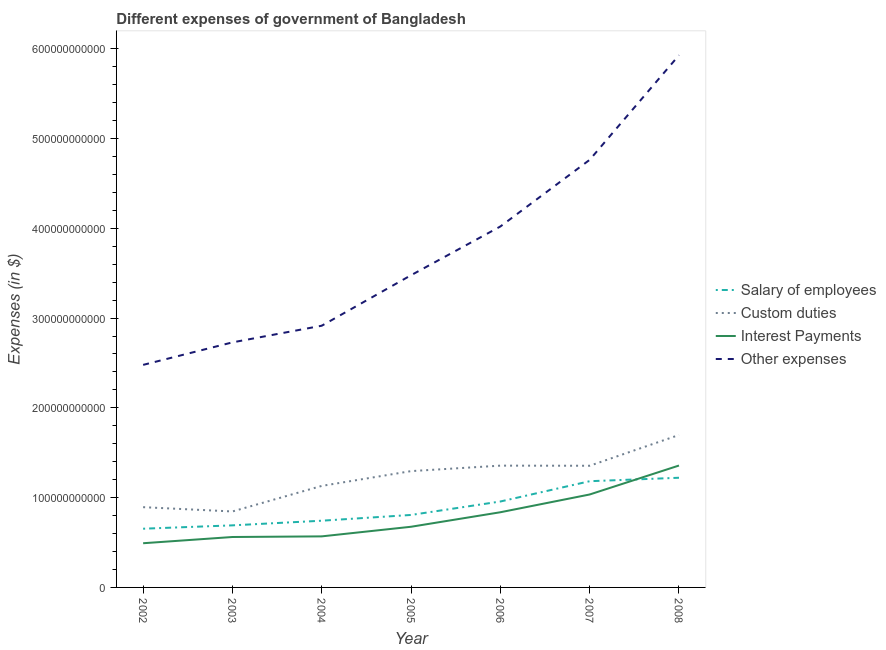Does the line corresponding to amount spent on custom duties intersect with the line corresponding to amount spent on other expenses?
Make the answer very short. No. Is the number of lines equal to the number of legend labels?
Your answer should be very brief. Yes. What is the amount spent on other expenses in 2006?
Provide a short and direct response. 4.02e+11. Across all years, what is the maximum amount spent on interest payments?
Your answer should be compact. 1.36e+11. Across all years, what is the minimum amount spent on salary of employees?
Offer a very short reply. 6.54e+1. In which year was the amount spent on salary of employees maximum?
Your answer should be compact. 2008. In which year was the amount spent on custom duties minimum?
Ensure brevity in your answer.  2003. What is the total amount spent on salary of employees in the graph?
Your answer should be very brief. 6.26e+11. What is the difference between the amount spent on custom duties in 2002 and that in 2003?
Your response must be concise. 4.78e+09. What is the difference between the amount spent on salary of employees in 2006 and the amount spent on other expenses in 2008?
Keep it short and to the point. -4.97e+11. What is the average amount spent on other expenses per year?
Your answer should be very brief. 3.76e+11. In the year 2008, what is the difference between the amount spent on custom duties and amount spent on interest payments?
Make the answer very short. 3.40e+1. What is the ratio of the amount spent on interest payments in 2007 to that in 2008?
Provide a short and direct response. 0.76. Is the amount spent on interest payments in 2004 less than that in 2007?
Offer a very short reply. Yes. What is the difference between the highest and the second highest amount spent on other expenses?
Offer a very short reply. 1.16e+11. What is the difference between the highest and the lowest amount spent on salary of employees?
Your response must be concise. 5.68e+1. Is the sum of the amount spent on other expenses in 2004 and 2008 greater than the maximum amount spent on interest payments across all years?
Keep it short and to the point. Yes. Is it the case that in every year, the sum of the amount spent on custom duties and amount spent on salary of employees is greater than the sum of amount spent on interest payments and amount spent on other expenses?
Offer a terse response. No. How many lines are there?
Make the answer very short. 4. What is the difference between two consecutive major ticks on the Y-axis?
Offer a very short reply. 1.00e+11. Are the values on the major ticks of Y-axis written in scientific E-notation?
Offer a terse response. No. Does the graph contain grids?
Make the answer very short. No. Where does the legend appear in the graph?
Make the answer very short. Center right. How are the legend labels stacked?
Keep it short and to the point. Vertical. What is the title of the graph?
Ensure brevity in your answer.  Different expenses of government of Bangladesh. What is the label or title of the X-axis?
Provide a succinct answer. Year. What is the label or title of the Y-axis?
Provide a succinct answer. Expenses (in $). What is the Expenses (in $) in Salary of employees in 2002?
Give a very brief answer. 6.54e+1. What is the Expenses (in $) of Custom duties in 2002?
Ensure brevity in your answer.  8.94e+1. What is the Expenses (in $) of Interest Payments in 2002?
Give a very brief answer. 4.92e+1. What is the Expenses (in $) of Other expenses in 2002?
Offer a terse response. 2.48e+11. What is the Expenses (in $) in Salary of employees in 2003?
Offer a very short reply. 6.91e+1. What is the Expenses (in $) in Custom duties in 2003?
Keep it short and to the point. 8.46e+1. What is the Expenses (in $) in Interest Payments in 2003?
Ensure brevity in your answer.  5.62e+1. What is the Expenses (in $) in Other expenses in 2003?
Give a very brief answer. 2.73e+11. What is the Expenses (in $) of Salary of employees in 2004?
Offer a very short reply. 7.43e+1. What is the Expenses (in $) of Custom duties in 2004?
Provide a succinct answer. 1.13e+11. What is the Expenses (in $) of Interest Payments in 2004?
Your answer should be compact. 5.69e+1. What is the Expenses (in $) of Other expenses in 2004?
Offer a very short reply. 2.91e+11. What is the Expenses (in $) in Salary of employees in 2005?
Give a very brief answer. 8.07e+1. What is the Expenses (in $) of Custom duties in 2005?
Your answer should be very brief. 1.30e+11. What is the Expenses (in $) of Interest Payments in 2005?
Offer a very short reply. 6.76e+1. What is the Expenses (in $) in Other expenses in 2005?
Provide a short and direct response. 3.48e+11. What is the Expenses (in $) of Salary of employees in 2006?
Keep it short and to the point. 9.57e+1. What is the Expenses (in $) of Custom duties in 2006?
Give a very brief answer. 1.36e+11. What is the Expenses (in $) in Interest Payments in 2006?
Provide a succinct answer. 8.37e+1. What is the Expenses (in $) in Other expenses in 2006?
Your response must be concise. 4.02e+11. What is the Expenses (in $) in Salary of employees in 2007?
Make the answer very short. 1.18e+11. What is the Expenses (in $) in Custom duties in 2007?
Offer a terse response. 1.36e+11. What is the Expenses (in $) in Interest Payments in 2007?
Offer a very short reply. 1.04e+11. What is the Expenses (in $) of Other expenses in 2007?
Your answer should be very brief. 4.76e+11. What is the Expenses (in $) of Salary of employees in 2008?
Keep it short and to the point. 1.22e+11. What is the Expenses (in $) of Custom duties in 2008?
Your answer should be very brief. 1.70e+11. What is the Expenses (in $) of Interest Payments in 2008?
Your answer should be compact. 1.36e+11. What is the Expenses (in $) in Other expenses in 2008?
Your answer should be very brief. 5.93e+11. Across all years, what is the maximum Expenses (in $) of Salary of employees?
Keep it short and to the point. 1.22e+11. Across all years, what is the maximum Expenses (in $) of Custom duties?
Keep it short and to the point. 1.70e+11. Across all years, what is the maximum Expenses (in $) in Interest Payments?
Offer a terse response. 1.36e+11. Across all years, what is the maximum Expenses (in $) of Other expenses?
Your response must be concise. 5.93e+11. Across all years, what is the minimum Expenses (in $) in Salary of employees?
Keep it short and to the point. 6.54e+1. Across all years, what is the minimum Expenses (in $) of Custom duties?
Your response must be concise. 8.46e+1. Across all years, what is the minimum Expenses (in $) in Interest Payments?
Ensure brevity in your answer.  4.92e+1. Across all years, what is the minimum Expenses (in $) in Other expenses?
Provide a succinct answer. 2.48e+11. What is the total Expenses (in $) of Salary of employees in the graph?
Ensure brevity in your answer.  6.26e+11. What is the total Expenses (in $) in Custom duties in the graph?
Offer a very short reply. 8.58e+11. What is the total Expenses (in $) of Interest Payments in the graph?
Provide a succinct answer. 5.53e+11. What is the total Expenses (in $) in Other expenses in the graph?
Provide a short and direct response. 2.63e+12. What is the difference between the Expenses (in $) of Salary of employees in 2002 and that in 2003?
Ensure brevity in your answer.  -3.74e+09. What is the difference between the Expenses (in $) of Custom duties in 2002 and that in 2003?
Make the answer very short. 4.78e+09. What is the difference between the Expenses (in $) of Interest Payments in 2002 and that in 2003?
Offer a terse response. -6.94e+09. What is the difference between the Expenses (in $) of Other expenses in 2002 and that in 2003?
Your answer should be very brief. -2.51e+1. What is the difference between the Expenses (in $) in Salary of employees in 2002 and that in 2004?
Offer a very short reply. -8.92e+09. What is the difference between the Expenses (in $) of Custom duties in 2002 and that in 2004?
Keep it short and to the point. -2.37e+1. What is the difference between the Expenses (in $) in Interest Payments in 2002 and that in 2004?
Offer a terse response. -7.65e+09. What is the difference between the Expenses (in $) in Other expenses in 2002 and that in 2004?
Offer a very short reply. -4.36e+1. What is the difference between the Expenses (in $) of Salary of employees in 2002 and that in 2005?
Your answer should be very brief. -1.53e+1. What is the difference between the Expenses (in $) of Custom duties in 2002 and that in 2005?
Offer a terse response. -4.02e+1. What is the difference between the Expenses (in $) of Interest Payments in 2002 and that in 2005?
Ensure brevity in your answer.  -1.84e+1. What is the difference between the Expenses (in $) of Other expenses in 2002 and that in 2005?
Your answer should be very brief. -9.99e+1. What is the difference between the Expenses (in $) of Salary of employees in 2002 and that in 2006?
Make the answer very short. -3.03e+1. What is the difference between the Expenses (in $) of Custom duties in 2002 and that in 2006?
Your answer should be very brief. -4.63e+1. What is the difference between the Expenses (in $) of Interest Payments in 2002 and that in 2006?
Make the answer very short. -3.45e+1. What is the difference between the Expenses (in $) of Other expenses in 2002 and that in 2006?
Keep it short and to the point. -1.54e+11. What is the difference between the Expenses (in $) in Salary of employees in 2002 and that in 2007?
Offer a terse response. -5.29e+1. What is the difference between the Expenses (in $) in Custom duties in 2002 and that in 2007?
Provide a succinct answer. -4.61e+1. What is the difference between the Expenses (in $) of Interest Payments in 2002 and that in 2007?
Your response must be concise. -5.43e+1. What is the difference between the Expenses (in $) of Other expenses in 2002 and that in 2007?
Offer a very short reply. -2.28e+11. What is the difference between the Expenses (in $) of Salary of employees in 2002 and that in 2008?
Provide a succinct answer. -5.68e+1. What is the difference between the Expenses (in $) of Custom duties in 2002 and that in 2008?
Offer a very short reply. -8.04e+1. What is the difference between the Expenses (in $) of Interest Payments in 2002 and that in 2008?
Your response must be concise. -8.66e+1. What is the difference between the Expenses (in $) of Other expenses in 2002 and that in 2008?
Provide a short and direct response. -3.45e+11. What is the difference between the Expenses (in $) of Salary of employees in 2003 and that in 2004?
Your answer should be compact. -5.18e+09. What is the difference between the Expenses (in $) in Custom duties in 2003 and that in 2004?
Your response must be concise. -2.85e+1. What is the difference between the Expenses (in $) in Interest Payments in 2003 and that in 2004?
Offer a terse response. -7.04e+08. What is the difference between the Expenses (in $) of Other expenses in 2003 and that in 2004?
Make the answer very short. -1.85e+1. What is the difference between the Expenses (in $) in Salary of employees in 2003 and that in 2005?
Give a very brief answer. -1.16e+1. What is the difference between the Expenses (in $) of Custom duties in 2003 and that in 2005?
Provide a short and direct response. -4.49e+1. What is the difference between the Expenses (in $) of Interest Payments in 2003 and that in 2005?
Ensure brevity in your answer.  -1.14e+1. What is the difference between the Expenses (in $) of Other expenses in 2003 and that in 2005?
Ensure brevity in your answer.  -7.48e+1. What is the difference between the Expenses (in $) of Salary of employees in 2003 and that in 2006?
Offer a very short reply. -2.66e+1. What is the difference between the Expenses (in $) of Custom duties in 2003 and that in 2006?
Offer a very short reply. -5.10e+1. What is the difference between the Expenses (in $) in Interest Payments in 2003 and that in 2006?
Your response must be concise. -2.76e+1. What is the difference between the Expenses (in $) in Other expenses in 2003 and that in 2006?
Give a very brief answer. -1.29e+11. What is the difference between the Expenses (in $) in Salary of employees in 2003 and that in 2007?
Ensure brevity in your answer.  -4.92e+1. What is the difference between the Expenses (in $) in Custom duties in 2003 and that in 2007?
Offer a very short reply. -5.09e+1. What is the difference between the Expenses (in $) in Interest Payments in 2003 and that in 2007?
Provide a short and direct response. -4.74e+1. What is the difference between the Expenses (in $) of Other expenses in 2003 and that in 2007?
Keep it short and to the point. -2.03e+11. What is the difference between the Expenses (in $) of Salary of employees in 2003 and that in 2008?
Ensure brevity in your answer.  -5.30e+1. What is the difference between the Expenses (in $) of Custom duties in 2003 and that in 2008?
Provide a short and direct response. -8.52e+1. What is the difference between the Expenses (in $) in Interest Payments in 2003 and that in 2008?
Provide a succinct answer. -7.96e+1. What is the difference between the Expenses (in $) of Other expenses in 2003 and that in 2008?
Give a very brief answer. -3.20e+11. What is the difference between the Expenses (in $) of Salary of employees in 2004 and that in 2005?
Keep it short and to the point. -6.42e+09. What is the difference between the Expenses (in $) of Custom duties in 2004 and that in 2005?
Keep it short and to the point. -1.65e+1. What is the difference between the Expenses (in $) of Interest Payments in 2004 and that in 2005?
Offer a terse response. -1.07e+1. What is the difference between the Expenses (in $) of Other expenses in 2004 and that in 2005?
Offer a terse response. -5.63e+1. What is the difference between the Expenses (in $) of Salary of employees in 2004 and that in 2006?
Provide a succinct answer. -2.14e+1. What is the difference between the Expenses (in $) in Custom duties in 2004 and that in 2006?
Your answer should be compact. -2.26e+1. What is the difference between the Expenses (in $) of Interest Payments in 2004 and that in 2006?
Ensure brevity in your answer.  -2.69e+1. What is the difference between the Expenses (in $) in Other expenses in 2004 and that in 2006?
Give a very brief answer. -1.11e+11. What is the difference between the Expenses (in $) in Salary of employees in 2004 and that in 2007?
Provide a succinct answer. -4.40e+1. What is the difference between the Expenses (in $) of Custom duties in 2004 and that in 2007?
Make the answer very short. -2.24e+1. What is the difference between the Expenses (in $) of Interest Payments in 2004 and that in 2007?
Your response must be concise. -4.67e+1. What is the difference between the Expenses (in $) in Other expenses in 2004 and that in 2007?
Give a very brief answer. -1.85e+11. What is the difference between the Expenses (in $) of Salary of employees in 2004 and that in 2008?
Your answer should be very brief. -4.78e+1. What is the difference between the Expenses (in $) of Custom duties in 2004 and that in 2008?
Provide a short and direct response. -5.67e+1. What is the difference between the Expenses (in $) in Interest Payments in 2004 and that in 2008?
Your answer should be very brief. -7.89e+1. What is the difference between the Expenses (in $) of Other expenses in 2004 and that in 2008?
Offer a very short reply. -3.01e+11. What is the difference between the Expenses (in $) of Salary of employees in 2005 and that in 2006?
Your answer should be very brief. -1.50e+1. What is the difference between the Expenses (in $) of Custom duties in 2005 and that in 2006?
Provide a succinct answer. -6.10e+09. What is the difference between the Expenses (in $) of Interest Payments in 2005 and that in 2006?
Provide a short and direct response. -1.62e+1. What is the difference between the Expenses (in $) in Other expenses in 2005 and that in 2006?
Offer a very short reply. -5.43e+1. What is the difference between the Expenses (in $) of Salary of employees in 2005 and that in 2007?
Ensure brevity in your answer.  -3.76e+1. What is the difference between the Expenses (in $) in Custom duties in 2005 and that in 2007?
Ensure brevity in your answer.  -5.96e+09. What is the difference between the Expenses (in $) of Interest Payments in 2005 and that in 2007?
Your answer should be very brief. -3.59e+1. What is the difference between the Expenses (in $) of Other expenses in 2005 and that in 2007?
Ensure brevity in your answer.  -1.29e+11. What is the difference between the Expenses (in $) of Salary of employees in 2005 and that in 2008?
Keep it short and to the point. -4.14e+1. What is the difference between the Expenses (in $) in Custom duties in 2005 and that in 2008?
Your answer should be very brief. -4.02e+1. What is the difference between the Expenses (in $) of Interest Payments in 2005 and that in 2008?
Provide a short and direct response. -6.82e+1. What is the difference between the Expenses (in $) in Other expenses in 2005 and that in 2008?
Make the answer very short. -2.45e+11. What is the difference between the Expenses (in $) of Salary of employees in 2006 and that in 2007?
Make the answer very short. -2.26e+1. What is the difference between the Expenses (in $) in Custom duties in 2006 and that in 2007?
Offer a terse response. 1.33e+08. What is the difference between the Expenses (in $) of Interest Payments in 2006 and that in 2007?
Offer a very short reply. -1.98e+1. What is the difference between the Expenses (in $) in Other expenses in 2006 and that in 2007?
Give a very brief answer. -7.43e+1. What is the difference between the Expenses (in $) of Salary of employees in 2006 and that in 2008?
Provide a succinct answer. -2.65e+1. What is the difference between the Expenses (in $) in Custom duties in 2006 and that in 2008?
Provide a short and direct response. -3.41e+1. What is the difference between the Expenses (in $) of Interest Payments in 2006 and that in 2008?
Give a very brief answer. -5.20e+1. What is the difference between the Expenses (in $) of Other expenses in 2006 and that in 2008?
Keep it short and to the point. -1.91e+11. What is the difference between the Expenses (in $) of Salary of employees in 2007 and that in 2008?
Your response must be concise. -3.86e+09. What is the difference between the Expenses (in $) of Custom duties in 2007 and that in 2008?
Your answer should be very brief. -3.43e+1. What is the difference between the Expenses (in $) of Interest Payments in 2007 and that in 2008?
Your answer should be very brief. -3.23e+1. What is the difference between the Expenses (in $) of Other expenses in 2007 and that in 2008?
Your answer should be very brief. -1.16e+11. What is the difference between the Expenses (in $) of Salary of employees in 2002 and the Expenses (in $) of Custom duties in 2003?
Ensure brevity in your answer.  -1.92e+1. What is the difference between the Expenses (in $) of Salary of employees in 2002 and the Expenses (in $) of Interest Payments in 2003?
Ensure brevity in your answer.  9.23e+09. What is the difference between the Expenses (in $) of Salary of employees in 2002 and the Expenses (in $) of Other expenses in 2003?
Your response must be concise. -2.08e+11. What is the difference between the Expenses (in $) in Custom duties in 2002 and the Expenses (in $) in Interest Payments in 2003?
Offer a terse response. 3.32e+1. What is the difference between the Expenses (in $) of Custom duties in 2002 and the Expenses (in $) of Other expenses in 2003?
Provide a short and direct response. -1.84e+11. What is the difference between the Expenses (in $) in Interest Payments in 2002 and the Expenses (in $) in Other expenses in 2003?
Your answer should be very brief. -2.24e+11. What is the difference between the Expenses (in $) in Salary of employees in 2002 and the Expenses (in $) in Custom duties in 2004?
Offer a very short reply. -4.77e+1. What is the difference between the Expenses (in $) of Salary of employees in 2002 and the Expenses (in $) of Interest Payments in 2004?
Keep it short and to the point. 8.53e+09. What is the difference between the Expenses (in $) in Salary of employees in 2002 and the Expenses (in $) in Other expenses in 2004?
Keep it short and to the point. -2.26e+11. What is the difference between the Expenses (in $) in Custom duties in 2002 and the Expenses (in $) in Interest Payments in 2004?
Give a very brief answer. 3.25e+1. What is the difference between the Expenses (in $) in Custom duties in 2002 and the Expenses (in $) in Other expenses in 2004?
Ensure brevity in your answer.  -2.02e+11. What is the difference between the Expenses (in $) of Interest Payments in 2002 and the Expenses (in $) of Other expenses in 2004?
Your answer should be compact. -2.42e+11. What is the difference between the Expenses (in $) in Salary of employees in 2002 and the Expenses (in $) in Custom duties in 2005?
Make the answer very short. -6.42e+1. What is the difference between the Expenses (in $) in Salary of employees in 2002 and the Expenses (in $) in Interest Payments in 2005?
Provide a short and direct response. -2.18e+09. What is the difference between the Expenses (in $) in Salary of employees in 2002 and the Expenses (in $) in Other expenses in 2005?
Ensure brevity in your answer.  -2.82e+11. What is the difference between the Expenses (in $) of Custom duties in 2002 and the Expenses (in $) of Interest Payments in 2005?
Your answer should be very brief. 2.18e+1. What is the difference between the Expenses (in $) in Custom duties in 2002 and the Expenses (in $) in Other expenses in 2005?
Make the answer very short. -2.58e+11. What is the difference between the Expenses (in $) of Interest Payments in 2002 and the Expenses (in $) of Other expenses in 2005?
Ensure brevity in your answer.  -2.99e+11. What is the difference between the Expenses (in $) in Salary of employees in 2002 and the Expenses (in $) in Custom duties in 2006?
Offer a terse response. -7.03e+1. What is the difference between the Expenses (in $) of Salary of employees in 2002 and the Expenses (in $) of Interest Payments in 2006?
Give a very brief answer. -1.83e+1. What is the difference between the Expenses (in $) of Salary of employees in 2002 and the Expenses (in $) of Other expenses in 2006?
Ensure brevity in your answer.  -3.37e+11. What is the difference between the Expenses (in $) of Custom duties in 2002 and the Expenses (in $) of Interest Payments in 2006?
Your response must be concise. 5.66e+09. What is the difference between the Expenses (in $) in Custom duties in 2002 and the Expenses (in $) in Other expenses in 2006?
Ensure brevity in your answer.  -3.13e+11. What is the difference between the Expenses (in $) in Interest Payments in 2002 and the Expenses (in $) in Other expenses in 2006?
Your response must be concise. -3.53e+11. What is the difference between the Expenses (in $) of Salary of employees in 2002 and the Expenses (in $) of Custom duties in 2007?
Provide a succinct answer. -7.01e+1. What is the difference between the Expenses (in $) in Salary of employees in 2002 and the Expenses (in $) in Interest Payments in 2007?
Your answer should be compact. -3.81e+1. What is the difference between the Expenses (in $) of Salary of employees in 2002 and the Expenses (in $) of Other expenses in 2007?
Offer a very short reply. -4.11e+11. What is the difference between the Expenses (in $) of Custom duties in 2002 and the Expenses (in $) of Interest Payments in 2007?
Offer a terse response. -1.41e+1. What is the difference between the Expenses (in $) of Custom duties in 2002 and the Expenses (in $) of Other expenses in 2007?
Offer a very short reply. -3.87e+11. What is the difference between the Expenses (in $) in Interest Payments in 2002 and the Expenses (in $) in Other expenses in 2007?
Make the answer very short. -4.27e+11. What is the difference between the Expenses (in $) in Salary of employees in 2002 and the Expenses (in $) in Custom duties in 2008?
Provide a succinct answer. -1.04e+11. What is the difference between the Expenses (in $) in Salary of employees in 2002 and the Expenses (in $) in Interest Payments in 2008?
Provide a succinct answer. -7.04e+1. What is the difference between the Expenses (in $) of Salary of employees in 2002 and the Expenses (in $) of Other expenses in 2008?
Make the answer very short. -5.27e+11. What is the difference between the Expenses (in $) of Custom duties in 2002 and the Expenses (in $) of Interest Payments in 2008?
Make the answer very short. -4.64e+1. What is the difference between the Expenses (in $) in Custom duties in 2002 and the Expenses (in $) in Other expenses in 2008?
Keep it short and to the point. -5.03e+11. What is the difference between the Expenses (in $) of Interest Payments in 2002 and the Expenses (in $) of Other expenses in 2008?
Your answer should be very brief. -5.44e+11. What is the difference between the Expenses (in $) of Salary of employees in 2003 and the Expenses (in $) of Custom duties in 2004?
Provide a short and direct response. -4.39e+1. What is the difference between the Expenses (in $) of Salary of employees in 2003 and the Expenses (in $) of Interest Payments in 2004?
Your answer should be very brief. 1.23e+1. What is the difference between the Expenses (in $) of Salary of employees in 2003 and the Expenses (in $) of Other expenses in 2004?
Give a very brief answer. -2.22e+11. What is the difference between the Expenses (in $) in Custom duties in 2003 and the Expenses (in $) in Interest Payments in 2004?
Ensure brevity in your answer.  2.77e+1. What is the difference between the Expenses (in $) in Custom duties in 2003 and the Expenses (in $) in Other expenses in 2004?
Offer a terse response. -2.07e+11. What is the difference between the Expenses (in $) in Interest Payments in 2003 and the Expenses (in $) in Other expenses in 2004?
Provide a short and direct response. -2.35e+11. What is the difference between the Expenses (in $) in Salary of employees in 2003 and the Expenses (in $) in Custom duties in 2005?
Provide a short and direct response. -6.04e+1. What is the difference between the Expenses (in $) in Salary of employees in 2003 and the Expenses (in $) in Interest Payments in 2005?
Your answer should be compact. 1.56e+09. What is the difference between the Expenses (in $) of Salary of employees in 2003 and the Expenses (in $) of Other expenses in 2005?
Your response must be concise. -2.79e+11. What is the difference between the Expenses (in $) of Custom duties in 2003 and the Expenses (in $) of Interest Payments in 2005?
Your response must be concise. 1.70e+1. What is the difference between the Expenses (in $) of Custom duties in 2003 and the Expenses (in $) of Other expenses in 2005?
Provide a succinct answer. -2.63e+11. What is the difference between the Expenses (in $) in Interest Payments in 2003 and the Expenses (in $) in Other expenses in 2005?
Keep it short and to the point. -2.92e+11. What is the difference between the Expenses (in $) of Salary of employees in 2003 and the Expenses (in $) of Custom duties in 2006?
Your answer should be very brief. -6.65e+1. What is the difference between the Expenses (in $) in Salary of employees in 2003 and the Expenses (in $) in Interest Payments in 2006?
Provide a succinct answer. -1.46e+1. What is the difference between the Expenses (in $) of Salary of employees in 2003 and the Expenses (in $) of Other expenses in 2006?
Give a very brief answer. -3.33e+11. What is the difference between the Expenses (in $) in Custom duties in 2003 and the Expenses (in $) in Interest Payments in 2006?
Your response must be concise. 8.74e+08. What is the difference between the Expenses (in $) in Custom duties in 2003 and the Expenses (in $) in Other expenses in 2006?
Your response must be concise. -3.17e+11. What is the difference between the Expenses (in $) in Interest Payments in 2003 and the Expenses (in $) in Other expenses in 2006?
Your response must be concise. -3.46e+11. What is the difference between the Expenses (in $) in Salary of employees in 2003 and the Expenses (in $) in Custom duties in 2007?
Ensure brevity in your answer.  -6.64e+1. What is the difference between the Expenses (in $) of Salary of employees in 2003 and the Expenses (in $) of Interest Payments in 2007?
Offer a very short reply. -3.44e+1. What is the difference between the Expenses (in $) of Salary of employees in 2003 and the Expenses (in $) of Other expenses in 2007?
Offer a very short reply. -4.07e+11. What is the difference between the Expenses (in $) of Custom duties in 2003 and the Expenses (in $) of Interest Payments in 2007?
Provide a succinct answer. -1.89e+1. What is the difference between the Expenses (in $) in Custom duties in 2003 and the Expenses (in $) in Other expenses in 2007?
Keep it short and to the point. -3.92e+11. What is the difference between the Expenses (in $) of Interest Payments in 2003 and the Expenses (in $) of Other expenses in 2007?
Offer a terse response. -4.20e+11. What is the difference between the Expenses (in $) of Salary of employees in 2003 and the Expenses (in $) of Custom duties in 2008?
Provide a succinct answer. -1.01e+11. What is the difference between the Expenses (in $) of Salary of employees in 2003 and the Expenses (in $) of Interest Payments in 2008?
Provide a short and direct response. -6.66e+1. What is the difference between the Expenses (in $) in Salary of employees in 2003 and the Expenses (in $) in Other expenses in 2008?
Offer a terse response. -5.24e+11. What is the difference between the Expenses (in $) of Custom duties in 2003 and the Expenses (in $) of Interest Payments in 2008?
Your response must be concise. -5.12e+1. What is the difference between the Expenses (in $) of Custom duties in 2003 and the Expenses (in $) of Other expenses in 2008?
Your answer should be compact. -5.08e+11. What is the difference between the Expenses (in $) of Interest Payments in 2003 and the Expenses (in $) of Other expenses in 2008?
Keep it short and to the point. -5.37e+11. What is the difference between the Expenses (in $) of Salary of employees in 2004 and the Expenses (in $) of Custom duties in 2005?
Make the answer very short. -5.52e+1. What is the difference between the Expenses (in $) of Salary of employees in 2004 and the Expenses (in $) of Interest Payments in 2005?
Keep it short and to the point. 6.74e+09. What is the difference between the Expenses (in $) of Salary of employees in 2004 and the Expenses (in $) of Other expenses in 2005?
Offer a terse response. -2.73e+11. What is the difference between the Expenses (in $) of Custom duties in 2004 and the Expenses (in $) of Interest Payments in 2005?
Offer a terse response. 4.55e+1. What is the difference between the Expenses (in $) of Custom duties in 2004 and the Expenses (in $) of Other expenses in 2005?
Keep it short and to the point. -2.35e+11. What is the difference between the Expenses (in $) in Interest Payments in 2004 and the Expenses (in $) in Other expenses in 2005?
Your response must be concise. -2.91e+11. What is the difference between the Expenses (in $) in Salary of employees in 2004 and the Expenses (in $) in Custom duties in 2006?
Your response must be concise. -6.13e+1. What is the difference between the Expenses (in $) in Salary of employees in 2004 and the Expenses (in $) in Interest Payments in 2006?
Your answer should be very brief. -9.42e+09. What is the difference between the Expenses (in $) in Salary of employees in 2004 and the Expenses (in $) in Other expenses in 2006?
Ensure brevity in your answer.  -3.28e+11. What is the difference between the Expenses (in $) in Custom duties in 2004 and the Expenses (in $) in Interest Payments in 2006?
Your answer should be compact. 2.93e+1. What is the difference between the Expenses (in $) in Custom duties in 2004 and the Expenses (in $) in Other expenses in 2006?
Give a very brief answer. -2.89e+11. What is the difference between the Expenses (in $) of Interest Payments in 2004 and the Expenses (in $) of Other expenses in 2006?
Provide a succinct answer. -3.45e+11. What is the difference between the Expenses (in $) in Salary of employees in 2004 and the Expenses (in $) in Custom duties in 2007?
Your answer should be compact. -6.12e+1. What is the difference between the Expenses (in $) of Salary of employees in 2004 and the Expenses (in $) of Interest Payments in 2007?
Provide a short and direct response. -2.92e+1. What is the difference between the Expenses (in $) in Salary of employees in 2004 and the Expenses (in $) in Other expenses in 2007?
Give a very brief answer. -4.02e+11. What is the difference between the Expenses (in $) in Custom duties in 2004 and the Expenses (in $) in Interest Payments in 2007?
Your response must be concise. 9.56e+09. What is the difference between the Expenses (in $) of Custom duties in 2004 and the Expenses (in $) of Other expenses in 2007?
Ensure brevity in your answer.  -3.63e+11. What is the difference between the Expenses (in $) of Interest Payments in 2004 and the Expenses (in $) of Other expenses in 2007?
Offer a terse response. -4.19e+11. What is the difference between the Expenses (in $) of Salary of employees in 2004 and the Expenses (in $) of Custom duties in 2008?
Give a very brief answer. -9.55e+1. What is the difference between the Expenses (in $) in Salary of employees in 2004 and the Expenses (in $) in Interest Payments in 2008?
Ensure brevity in your answer.  -6.15e+1. What is the difference between the Expenses (in $) of Salary of employees in 2004 and the Expenses (in $) of Other expenses in 2008?
Your answer should be very brief. -5.18e+11. What is the difference between the Expenses (in $) in Custom duties in 2004 and the Expenses (in $) in Interest Payments in 2008?
Make the answer very short. -2.27e+1. What is the difference between the Expenses (in $) of Custom duties in 2004 and the Expenses (in $) of Other expenses in 2008?
Keep it short and to the point. -4.80e+11. What is the difference between the Expenses (in $) of Interest Payments in 2004 and the Expenses (in $) of Other expenses in 2008?
Your answer should be very brief. -5.36e+11. What is the difference between the Expenses (in $) of Salary of employees in 2005 and the Expenses (in $) of Custom duties in 2006?
Offer a terse response. -5.49e+1. What is the difference between the Expenses (in $) in Salary of employees in 2005 and the Expenses (in $) in Interest Payments in 2006?
Provide a succinct answer. -3.01e+09. What is the difference between the Expenses (in $) in Salary of employees in 2005 and the Expenses (in $) in Other expenses in 2006?
Provide a short and direct response. -3.21e+11. What is the difference between the Expenses (in $) of Custom duties in 2005 and the Expenses (in $) of Interest Payments in 2006?
Your answer should be very brief. 4.58e+1. What is the difference between the Expenses (in $) of Custom duties in 2005 and the Expenses (in $) of Other expenses in 2006?
Provide a short and direct response. -2.72e+11. What is the difference between the Expenses (in $) of Interest Payments in 2005 and the Expenses (in $) of Other expenses in 2006?
Give a very brief answer. -3.34e+11. What is the difference between the Expenses (in $) in Salary of employees in 2005 and the Expenses (in $) in Custom duties in 2007?
Provide a succinct answer. -5.48e+1. What is the difference between the Expenses (in $) of Salary of employees in 2005 and the Expenses (in $) of Interest Payments in 2007?
Give a very brief answer. -2.28e+1. What is the difference between the Expenses (in $) of Salary of employees in 2005 and the Expenses (in $) of Other expenses in 2007?
Your response must be concise. -3.96e+11. What is the difference between the Expenses (in $) of Custom duties in 2005 and the Expenses (in $) of Interest Payments in 2007?
Ensure brevity in your answer.  2.60e+1. What is the difference between the Expenses (in $) of Custom duties in 2005 and the Expenses (in $) of Other expenses in 2007?
Your response must be concise. -3.47e+11. What is the difference between the Expenses (in $) in Interest Payments in 2005 and the Expenses (in $) in Other expenses in 2007?
Offer a terse response. -4.09e+11. What is the difference between the Expenses (in $) in Salary of employees in 2005 and the Expenses (in $) in Custom duties in 2008?
Offer a very short reply. -8.91e+1. What is the difference between the Expenses (in $) in Salary of employees in 2005 and the Expenses (in $) in Interest Payments in 2008?
Your response must be concise. -5.50e+1. What is the difference between the Expenses (in $) in Salary of employees in 2005 and the Expenses (in $) in Other expenses in 2008?
Your answer should be very brief. -5.12e+11. What is the difference between the Expenses (in $) of Custom duties in 2005 and the Expenses (in $) of Interest Payments in 2008?
Your response must be concise. -6.22e+09. What is the difference between the Expenses (in $) in Custom duties in 2005 and the Expenses (in $) in Other expenses in 2008?
Offer a very short reply. -4.63e+11. What is the difference between the Expenses (in $) of Interest Payments in 2005 and the Expenses (in $) of Other expenses in 2008?
Offer a terse response. -5.25e+11. What is the difference between the Expenses (in $) in Salary of employees in 2006 and the Expenses (in $) in Custom duties in 2007?
Make the answer very short. -3.98e+1. What is the difference between the Expenses (in $) of Salary of employees in 2006 and the Expenses (in $) of Interest Payments in 2007?
Provide a short and direct response. -7.81e+09. What is the difference between the Expenses (in $) of Salary of employees in 2006 and the Expenses (in $) of Other expenses in 2007?
Provide a short and direct response. -3.81e+11. What is the difference between the Expenses (in $) of Custom duties in 2006 and the Expenses (in $) of Interest Payments in 2007?
Offer a terse response. 3.21e+1. What is the difference between the Expenses (in $) in Custom duties in 2006 and the Expenses (in $) in Other expenses in 2007?
Provide a succinct answer. -3.41e+11. What is the difference between the Expenses (in $) in Interest Payments in 2006 and the Expenses (in $) in Other expenses in 2007?
Offer a terse response. -3.93e+11. What is the difference between the Expenses (in $) of Salary of employees in 2006 and the Expenses (in $) of Custom duties in 2008?
Your answer should be very brief. -7.41e+1. What is the difference between the Expenses (in $) of Salary of employees in 2006 and the Expenses (in $) of Interest Payments in 2008?
Your answer should be compact. -4.01e+1. What is the difference between the Expenses (in $) in Salary of employees in 2006 and the Expenses (in $) in Other expenses in 2008?
Keep it short and to the point. -4.97e+11. What is the difference between the Expenses (in $) in Custom duties in 2006 and the Expenses (in $) in Interest Payments in 2008?
Ensure brevity in your answer.  -1.19e+08. What is the difference between the Expenses (in $) in Custom duties in 2006 and the Expenses (in $) in Other expenses in 2008?
Your response must be concise. -4.57e+11. What is the difference between the Expenses (in $) of Interest Payments in 2006 and the Expenses (in $) of Other expenses in 2008?
Keep it short and to the point. -5.09e+11. What is the difference between the Expenses (in $) in Salary of employees in 2007 and the Expenses (in $) in Custom duties in 2008?
Make the answer very short. -5.15e+1. What is the difference between the Expenses (in $) of Salary of employees in 2007 and the Expenses (in $) of Interest Payments in 2008?
Your answer should be very brief. -1.75e+1. What is the difference between the Expenses (in $) of Salary of employees in 2007 and the Expenses (in $) of Other expenses in 2008?
Give a very brief answer. -4.74e+11. What is the difference between the Expenses (in $) in Custom duties in 2007 and the Expenses (in $) in Interest Payments in 2008?
Provide a succinct answer. -2.52e+08. What is the difference between the Expenses (in $) in Custom duties in 2007 and the Expenses (in $) in Other expenses in 2008?
Provide a succinct answer. -4.57e+11. What is the difference between the Expenses (in $) of Interest Payments in 2007 and the Expenses (in $) of Other expenses in 2008?
Your answer should be very brief. -4.89e+11. What is the average Expenses (in $) in Salary of employees per year?
Your answer should be compact. 8.94e+1. What is the average Expenses (in $) of Custom duties per year?
Your answer should be very brief. 1.23e+11. What is the average Expenses (in $) in Interest Payments per year?
Ensure brevity in your answer.  7.90e+1. What is the average Expenses (in $) in Other expenses per year?
Ensure brevity in your answer.  3.76e+11. In the year 2002, what is the difference between the Expenses (in $) in Salary of employees and Expenses (in $) in Custom duties?
Ensure brevity in your answer.  -2.40e+1. In the year 2002, what is the difference between the Expenses (in $) of Salary of employees and Expenses (in $) of Interest Payments?
Ensure brevity in your answer.  1.62e+1. In the year 2002, what is the difference between the Expenses (in $) in Salary of employees and Expenses (in $) in Other expenses?
Provide a succinct answer. -1.82e+11. In the year 2002, what is the difference between the Expenses (in $) of Custom duties and Expenses (in $) of Interest Payments?
Keep it short and to the point. 4.02e+1. In the year 2002, what is the difference between the Expenses (in $) of Custom duties and Expenses (in $) of Other expenses?
Your response must be concise. -1.58e+11. In the year 2002, what is the difference between the Expenses (in $) of Interest Payments and Expenses (in $) of Other expenses?
Give a very brief answer. -1.99e+11. In the year 2003, what is the difference between the Expenses (in $) in Salary of employees and Expenses (in $) in Custom duties?
Your answer should be compact. -1.55e+1. In the year 2003, what is the difference between the Expenses (in $) in Salary of employees and Expenses (in $) in Interest Payments?
Give a very brief answer. 1.30e+1. In the year 2003, what is the difference between the Expenses (in $) of Salary of employees and Expenses (in $) of Other expenses?
Give a very brief answer. -2.04e+11. In the year 2003, what is the difference between the Expenses (in $) in Custom duties and Expenses (in $) in Interest Payments?
Provide a succinct answer. 2.85e+1. In the year 2003, what is the difference between the Expenses (in $) in Custom duties and Expenses (in $) in Other expenses?
Give a very brief answer. -1.88e+11. In the year 2003, what is the difference between the Expenses (in $) in Interest Payments and Expenses (in $) in Other expenses?
Keep it short and to the point. -2.17e+11. In the year 2004, what is the difference between the Expenses (in $) of Salary of employees and Expenses (in $) of Custom duties?
Offer a very short reply. -3.88e+1. In the year 2004, what is the difference between the Expenses (in $) of Salary of employees and Expenses (in $) of Interest Payments?
Offer a terse response. 1.74e+1. In the year 2004, what is the difference between the Expenses (in $) in Salary of employees and Expenses (in $) in Other expenses?
Your answer should be compact. -2.17e+11. In the year 2004, what is the difference between the Expenses (in $) in Custom duties and Expenses (in $) in Interest Payments?
Provide a short and direct response. 5.62e+1. In the year 2004, what is the difference between the Expenses (in $) of Custom duties and Expenses (in $) of Other expenses?
Ensure brevity in your answer.  -1.78e+11. In the year 2004, what is the difference between the Expenses (in $) of Interest Payments and Expenses (in $) of Other expenses?
Give a very brief answer. -2.35e+11. In the year 2005, what is the difference between the Expenses (in $) in Salary of employees and Expenses (in $) in Custom duties?
Ensure brevity in your answer.  -4.88e+1. In the year 2005, what is the difference between the Expenses (in $) of Salary of employees and Expenses (in $) of Interest Payments?
Your response must be concise. 1.32e+1. In the year 2005, what is the difference between the Expenses (in $) of Salary of employees and Expenses (in $) of Other expenses?
Ensure brevity in your answer.  -2.67e+11. In the year 2005, what is the difference between the Expenses (in $) of Custom duties and Expenses (in $) of Interest Payments?
Make the answer very short. 6.20e+1. In the year 2005, what is the difference between the Expenses (in $) in Custom duties and Expenses (in $) in Other expenses?
Provide a succinct answer. -2.18e+11. In the year 2005, what is the difference between the Expenses (in $) in Interest Payments and Expenses (in $) in Other expenses?
Provide a succinct answer. -2.80e+11. In the year 2006, what is the difference between the Expenses (in $) in Salary of employees and Expenses (in $) in Custom duties?
Offer a very short reply. -3.99e+1. In the year 2006, what is the difference between the Expenses (in $) in Salary of employees and Expenses (in $) in Interest Payments?
Keep it short and to the point. 1.20e+1. In the year 2006, what is the difference between the Expenses (in $) of Salary of employees and Expenses (in $) of Other expenses?
Provide a succinct answer. -3.06e+11. In the year 2006, what is the difference between the Expenses (in $) in Custom duties and Expenses (in $) in Interest Payments?
Make the answer very short. 5.19e+1. In the year 2006, what is the difference between the Expenses (in $) in Custom duties and Expenses (in $) in Other expenses?
Your answer should be compact. -2.66e+11. In the year 2006, what is the difference between the Expenses (in $) of Interest Payments and Expenses (in $) of Other expenses?
Offer a very short reply. -3.18e+11. In the year 2007, what is the difference between the Expenses (in $) of Salary of employees and Expenses (in $) of Custom duties?
Provide a succinct answer. -1.72e+1. In the year 2007, what is the difference between the Expenses (in $) in Salary of employees and Expenses (in $) in Interest Payments?
Offer a very short reply. 1.48e+1. In the year 2007, what is the difference between the Expenses (in $) of Salary of employees and Expenses (in $) of Other expenses?
Keep it short and to the point. -3.58e+11. In the year 2007, what is the difference between the Expenses (in $) in Custom duties and Expenses (in $) in Interest Payments?
Provide a succinct answer. 3.20e+1. In the year 2007, what is the difference between the Expenses (in $) of Custom duties and Expenses (in $) of Other expenses?
Offer a terse response. -3.41e+11. In the year 2007, what is the difference between the Expenses (in $) of Interest Payments and Expenses (in $) of Other expenses?
Your response must be concise. -3.73e+11. In the year 2008, what is the difference between the Expenses (in $) in Salary of employees and Expenses (in $) in Custom duties?
Your response must be concise. -4.76e+1. In the year 2008, what is the difference between the Expenses (in $) of Salary of employees and Expenses (in $) of Interest Payments?
Make the answer very short. -1.36e+1. In the year 2008, what is the difference between the Expenses (in $) in Salary of employees and Expenses (in $) in Other expenses?
Your answer should be compact. -4.71e+11. In the year 2008, what is the difference between the Expenses (in $) of Custom duties and Expenses (in $) of Interest Payments?
Provide a short and direct response. 3.40e+1. In the year 2008, what is the difference between the Expenses (in $) of Custom duties and Expenses (in $) of Other expenses?
Provide a short and direct response. -4.23e+11. In the year 2008, what is the difference between the Expenses (in $) in Interest Payments and Expenses (in $) in Other expenses?
Keep it short and to the point. -4.57e+11. What is the ratio of the Expenses (in $) in Salary of employees in 2002 to that in 2003?
Make the answer very short. 0.95. What is the ratio of the Expenses (in $) in Custom duties in 2002 to that in 2003?
Offer a very short reply. 1.06. What is the ratio of the Expenses (in $) of Interest Payments in 2002 to that in 2003?
Your answer should be very brief. 0.88. What is the ratio of the Expenses (in $) of Other expenses in 2002 to that in 2003?
Your answer should be very brief. 0.91. What is the ratio of the Expenses (in $) of Salary of employees in 2002 to that in 2004?
Offer a very short reply. 0.88. What is the ratio of the Expenses (in $) of Custom duties in 2002 to that in 2004?
Your response must be concise. 0.79. What is the ratio of the Expenses (in $) in Interest Payments in 2002 to that in 2004?
Offer a terse response. 0.87. What is the ratio of the Expenses (in $) of Other expenses in 2002 to that in 2004?
Give a very brief answer. 0.85. What is the ratio of the Expenses (in $) of Salary of employees in 2002 to that in 2005?
Offer a terse response. 0.81. What is the ratio of the Expenses (in $) of Custom duties in 2002 to that in 2005?
Your answer should be compact. 0.69. What is the ratio of the Expenses (in $) in Interest Payments in 2002 to that in 2005?
Ensure brevity in your answer.  0.73. What is the ratio of the Expenses (in $) in Other expenses in 2002 to that in 2005?
Make the answer very short. 0.71. What is the ratio of the Expenses (in $) in Salary of employees in 2002 to that in 2006?
Provide a short and direct response. 0.68. What is the ratio of the Expenses (in $) of Custom duties in 2002 to that in 2006?
Your answer should be compact. 0.66. What is the ratio of the Expenses (in $) in Interest Payments in 2002 to that in 2006?
Give a very brief answer. 0.59. What is the ratio of the Expenses (in $) of Other expenses in 2002 to that in 2006?
Provide a short and direct response. 0.62. What is the ratio of the Expenses (in $) of Salary of employees in 2002 to that in 2007?
Make the answer very short. 0.55. What is the ratio of the Expenses (in $) in Custom duties in 2002 to that in 2007?
Provide a short and direct response. 0.66. What is the ratio of the Expenses (in $) of Interest Payments in 2002 to that in 2007?
Offer a very short reply. 0.48. What is the ratio of the Expenses (in $) in Other expenses in 2002 to that in 2007?
Your answer should be compact. 0.52. What is the ratio of the Expenses (in $) of Salary of employees in 2002 to that in 2008?
Give a very brief answer. 0.54. What is the ratio of the Expenses (in $) of Custom duties in 2002 to that in 2008?
Ensure brevity in your answer.  0.53. What is the ratio of the Expenses (in $) of Interest Payments in 2002 to that in 2008?
Provide a short and direct response. 0.36. What is the ratio of the Expenses (in $) in Other expenses in 2002 to that in 2008?
Provide a succinct answer. 0.42. What is the ratio of the Expenses (in $) of Salary of employees in 2003 to that in 2004?
Provide a succinct answer. 0.93. What is the ratio of the Expenses (in $) in Custom duties in 2003 to that in 2004?
Provide a succinct answer. 0.75. What is the ratio of the Expenses (in $) of Interest Payments in 2003 to that in 2004?
Make the answer very short. 0.99. What is the ratio of the Expenses (in $) in Other expenses in 2003 to that in 2004?
Your answer should be compact. 0.94. What is the ratio of the Expenses (in $) in Salary of employees in 2003 to that in 2005?
Make the answer very short. 0.86. What is the ratio of the Expenses (in $) in Custom duties in 2003 to that in 2005?
Make the answer very short. 0.65. What is the ratio of the Expenses (in $) in Interest Payments in 2003 to that in 2005?
Give a very brief answer. 0.83. What is the ratio of the Expenses (in $) of Other expenses in 2003 to that in 2005?
Ensure brevity in your answer.  0.78. What is the ratio of the Expenses (in $) in Salary of employees in 2003 to that in 2006?
Provide a succinct answer. 0.72. What is the ratio of the Expenses (in $) of Custom duties in 2003 to that in 2006?
Give a very brief answer. 0.62. What is the ratio of the Expenses (in $) of Interest Payments in 2003 to that in 2006?
Offer a terse response. 0.67. What is the ratio of the Expenses (in $) in Other expenses in 2003 to that in 2006?
Offer a very short reply. 0.68. What is the ratio of the Expenses (in $) of Salary of employees in 2003 to that in 2007?
Your response must be concise. 0.58. What is the ratio of the Expenses (in $) of Custom duties in 2003 to that in 2007?
Make the answer very short. 0.62. What is the ratio of the Expenses (in $) in Interest Payments in 2003 to that in 2007?
Offer a terse response. 0.54. What is the ratio of the Expenses (in $) of Other expenses in 2003 to that in 2007?
Provide a short and direct response. 0.57. What is the ratio of the Expenses (in $) in Salary of employees in 2003 to that in 2008?
Your answer should be compact. 0.57. What is the ratio of the Expenses (in $) of Custom duties in 2003 to that in 2008?
Ensure brevity in your answer.  0.5. What is the ratio of the Expenses (in $) in Interest Payments in 2003 to that in 2008?
Your response must be concise. 0.41. What is the ratio of the Expenses (in $) of Other expenses in 2003 to that in 2008?
Your answer should be very brief. 0.46. What is the ratio of the Expenses (in $) in Salary of employees in 2004 to that in 2005?
Provide a succinct answer. 0.92. What is the ratio of the Expenses (in $) of Custom duties in 2004 to that in 2005?
Provide a succinct answer. 0.87. What is the ratio of the Expenses (in $) of Interest Payments in 2004 to that in 2005?
Make the answer very short. 0.84. What is the ratio of the Expenses (in $) in Other expenses in 2004 to that in 2005?
Offer a very short reply. 0.84. What is the ratio of the Expenses (in $) of Salary of employees in 2004 to that in 2006?
Provide a succinct answer. 0.78. What is the ratio of the Expenses (in $) in Custom duties in 2004 to that in 2006?
Offer a terse response. 0.83. What is the ratio of the Expenses (in $) in Interest Payments in 2004 to that in 2006?
Keep it short and to the point. 0.68. What is the ratio of the Expenses (in $) in Other expenses in 2004 to that in 2006?
Offer a terse response. 0.73. What is the ratio of the Expenses (in $) of Salary of employees in 2004 to that in 2007?
Give a very brief answer. 0.63. What is the ratio of the Expenses (in $) in Custom duties in 2004 to that in 2007?
Keep it short and to the point. 0.83. What is the ratio of the Expenses (in $) of Interest Payments in 2004 to that in 2007?
Ensure brevity in your answer.  0.55. What is the ratio of the Expenses (in $) of Other expenses in 2004 to that in 2007?
Keep it short and to the point. 0.61. What is the ratio of the Expenses (in $) of Salary of employees in 2004 to that in 2008?
Provide a succinct answer. 0.61. What is the ratio of the Expenses (in $) in Custom duties in 2004 to that in 2008?
Provide a short and direct response. 0.67. What is the ratio of the Expenses (in $) in Interest Payments in 2004 to that in 2008?
Provide a succinct answer. 0.42. What is the ratio of the Expenses (in $) in Other expenses in 2004 to that in 2008?
Offer a terse response. 0.49. What is the ratio of the Expenses (in $) of Salary of employees in 2005 to that in 2006?
Offer a very short reply. 0.84. What is the ratio of the Expenses (in $) in Custom duties in 2005 to that in 2006?
Ensure brevity in your answer.  0.95. What is the ratio of the Expenses (in $) in Interest Payments in 2005 to that in 2006?
Keep it short and to the point. 0.81. What is the ratio of the Expenses (in $) of Other expenses in 2005 to that in 2006?
Provide a short and direct response. 0.86. What is the ratio of the Expenses (in $) in Salary of employees in 2005 to that in 2007?
Your answer should be very brief. 0.68. What is the ratio of the Expenses (in $) of Custom duties in 2005 to that in 2007?
Your answer should be compact. 0.96. What is the ratio of the Expenses (in $) of Interest Payments in 2005 to that in 2007?
Make the answer very short. 0.65. What is the ratio of the Expenses (in $) of Other expenses in 2005 to that in 2007?
Provide a short and direct response. 0.73. What is the ratio of the Expenses (in $) in Salary of employees in 2005 to that in 2008?
Ensure brevity in your answer.  0.66. What is the ratio of the Expenses (in $) in Custom duties in 2005 to that in 2008?
Your answer should be very brief. 0.76. What is the ratio of the Expenses (in $) in Interest Payments in 2005 to that in 2008?
Provide a short and direct response. 0.5. What is the ratio of the Expenses (in $) in Other expenses in 2005 to that in 2008?
Keep it short and to the point. 0.59. What is the ratio of the Expenses (in $) of Salary of employees in 2006 to that in 2007?
Make the answer very short. 0.81. What is the ratio of the Expenses (in $) of Interest Payments in 2006 to that in 2007?
Offer a very short reply. 0.81. What is the ratio of the Expenses (in $) in Other expenses in 2006 to that in 2007?
Offer a very short reply. 0.84. What is the ratio of the Expenses (in $) of Salary of employees in 2006 to that in 2008?
Your answer should be compact. 0.78. What is the ratio of the Expenses (in $) of Custom duties in 2006 to that in 2008?
Your answer should be compact. 0.8. What is the ratio of the Expenses (in $) in Interest Payments in 2006 to that in 2008?
Make the answer very short. 0.62. What is the ratio of the Expenses (in $) of Other expenses in 2006 to that in 2008?
Ensure brevity in your answer.  0.68. What is the ratio of the Expenses (in $) of Salary of employees in 2007 to that in 2008?
Your answer should be compact. 0.97. What is the ratio of the Expenses (in $) in Custom duties in 2007 to that in 2008?
Ensure brevity in your answer.  0.8. What is the ratio of the Expenses (in $) in Interest Payments in 2007 to that in 2008?
Give a very brief answer. 0.76. What is the ratio of the Expenses (in $) in Other expenses in 2007 to that in 2008?
Offer a terse response. 0.8. What is the difference between the highest and the second highest Expenses (in $) in Salary of employees?
Make the answer very short. 3.86e+09. What is the difference between the highest and the second highest Expenses (in $) in Custom duties?
Your answer should be compact. 3.41e+1. What is the difference between the highest and the second highest Expenses (in $) in Interest Payments?
Make the answer very short. 3.23e+1. What is the difference between the highest and the second highest Expenses (in $) of Other expenses?
Your answer should be very brief. 1.16e+11. What is the difference between the highest and the lowest Expenses (in $) of Salary of employees?
Make the answer very short. 5.68e+1. What is the difference between the highest and the lowest Expenses (in $) of Custom duties?
Your response must be concise. 8.52e+1. What is the difference between the highest and the lowest Expenses (in $) in Interest Payments?
Provide a succinct answer. 8.66e+1. What is the difference between the highest and the lowest Expenses (in $) in Other expenses?
Give a very brief answer. 3.45e+11. 